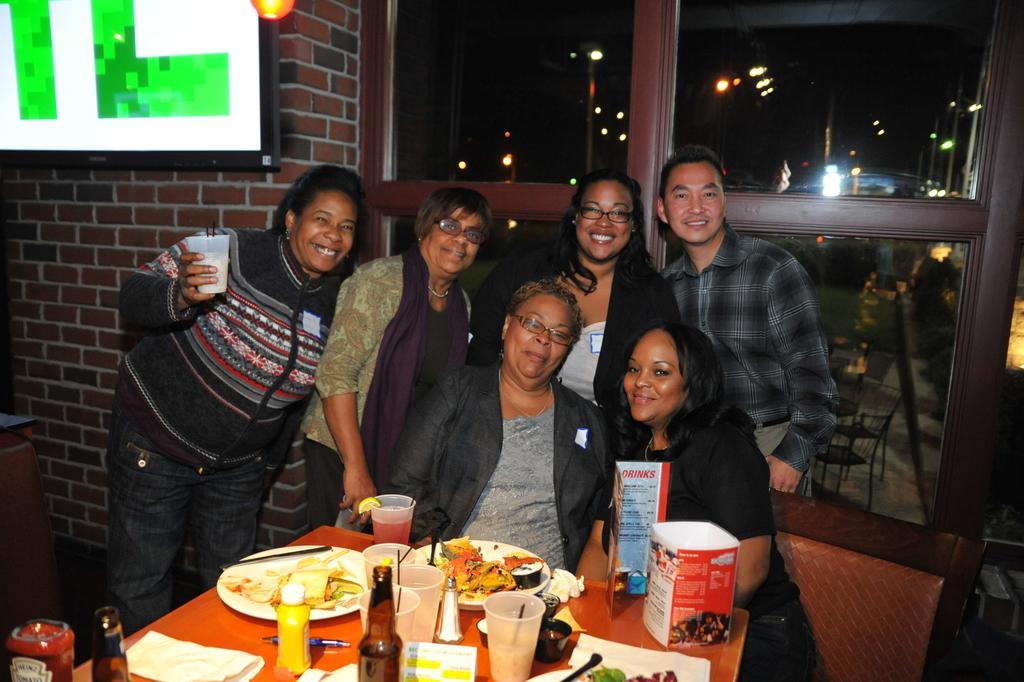Could you give a brief overview of what you see in this image? In the center of the image some persons are there. At the bottom of the image there is a table. On the table we can see bottles, glasses, plate of food, fork, spoon, paper, box, pen are there. In the background of the image we can see door, wall, screen, lights, chairs are there. At the top of the image sky is there. 